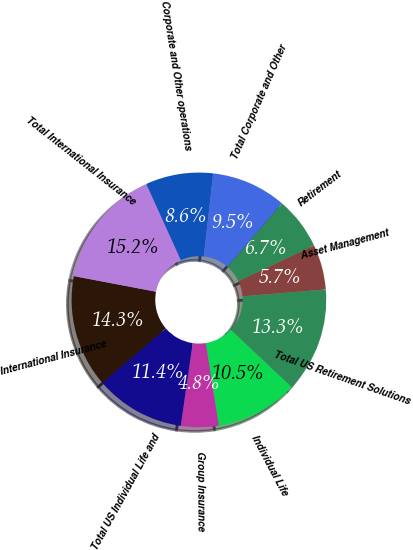Convert chart to OTSL. <chart><loc_0><loc_0><loc_500><loc_500><pie_chart><fcel>Retirement<fcel>Asset Management<fcel>Total US Retirement Solutions<fcel>Individual Life<fcel>Group Insurance<fcel>Total US Individual Life and<fcel>International Insurance<fcel>Total International Insurance<fcel>Corporate and Other operations<fcel>Total Corporate and Other<nl><fcel>6.67%<fcel>5.72%<fcel>13.33%<fcel>10.48%<fcel>4.77%<fcel>11.43%<fcel>14.28%<fcel>15.23%<fcel>8.57%<fcel>9.52%<nl></chart> 